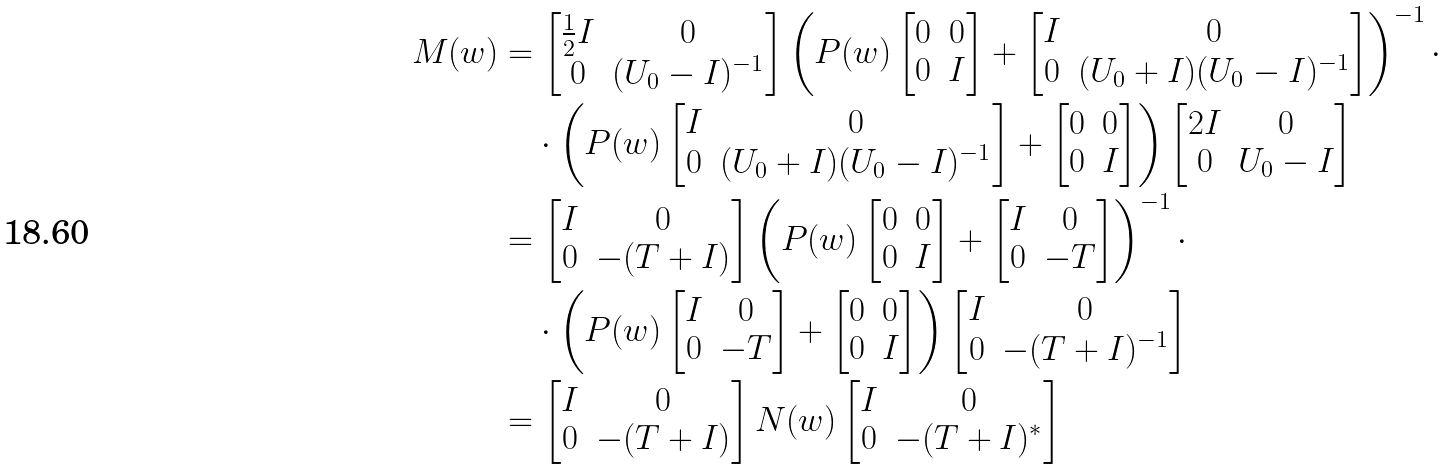<formula> <loc_0><loc_0><loc_500><loc_500>M ( w ) & = \left [ \begin{matrix} \frac { 1 } { 2 } I & 0 \\ 0 & ( U _ { 0 } - I ) ^ { - 1 } \end{matrix} \right ] \left ( P ( w ) \left [ \begin{matrix} 0 & 0 \\ 0 & I \end{matrix} \right ] + \left [ \begin{matrix} I & 0 \\ 0 & ( U _ { 0 } + I ) ( U _ { 0 } - I ) ^ { - 1 } \end{matrix} \right ] \right ) ^ { - 1 } \cdot \\ & \quad \cdot \left ( P ( w ) \left [ \begin{matrix} I & 0 \\ 0 & ( U _ { 0 } + I ) ( U _ { 0 } - I ) ^ { - 1 } \end{matrix} \right ] + \left [ \begin{matrix} 0 & 0 \\ 0 & I \end{matrix} \right ] \right ) \left [ \begin{matrix} 2 I & 0 \\ 0 & U _ { 0 } - I \end{matrix} \right ] \\ & = \left [ \begin{matrix} I & 0 \\ 0 & - ( T + I ) \end{matrix} \right ] \left ( P ( w ) \left [ \begin{matrix} 0 & 0 \\ 0 & I \end{matrix} \right ] + \left [ \begin{matrix} I & 0 \\ 0 & - T \end{matrix} \right ] \right ) ^ { - 1 } \cdot \\ & \quad \cdot \left ( P ( w ) \left [ \begin{matrix} I & 0 \\ 0 & - T \end{matrix} \right ] + \left [ \begin{matrix} 0 & 0 \\ 0 & I \end{matrix} \right ] \right ) \left [ \begin{matrix} I & 0 \\ 0 & - ( T + I ) ^ { - 1 } \end{matrix} \right ] \\ & = \left [ \begin{matrix} I & 0 \\ 0 & - ( T + I ) \end{matrix} \right ] N ( w ) \left [ \begin{matrix} I & 0 \\ 0 & - ( T + I ) ^ { * } \end{matrix} \right ]</formula> 